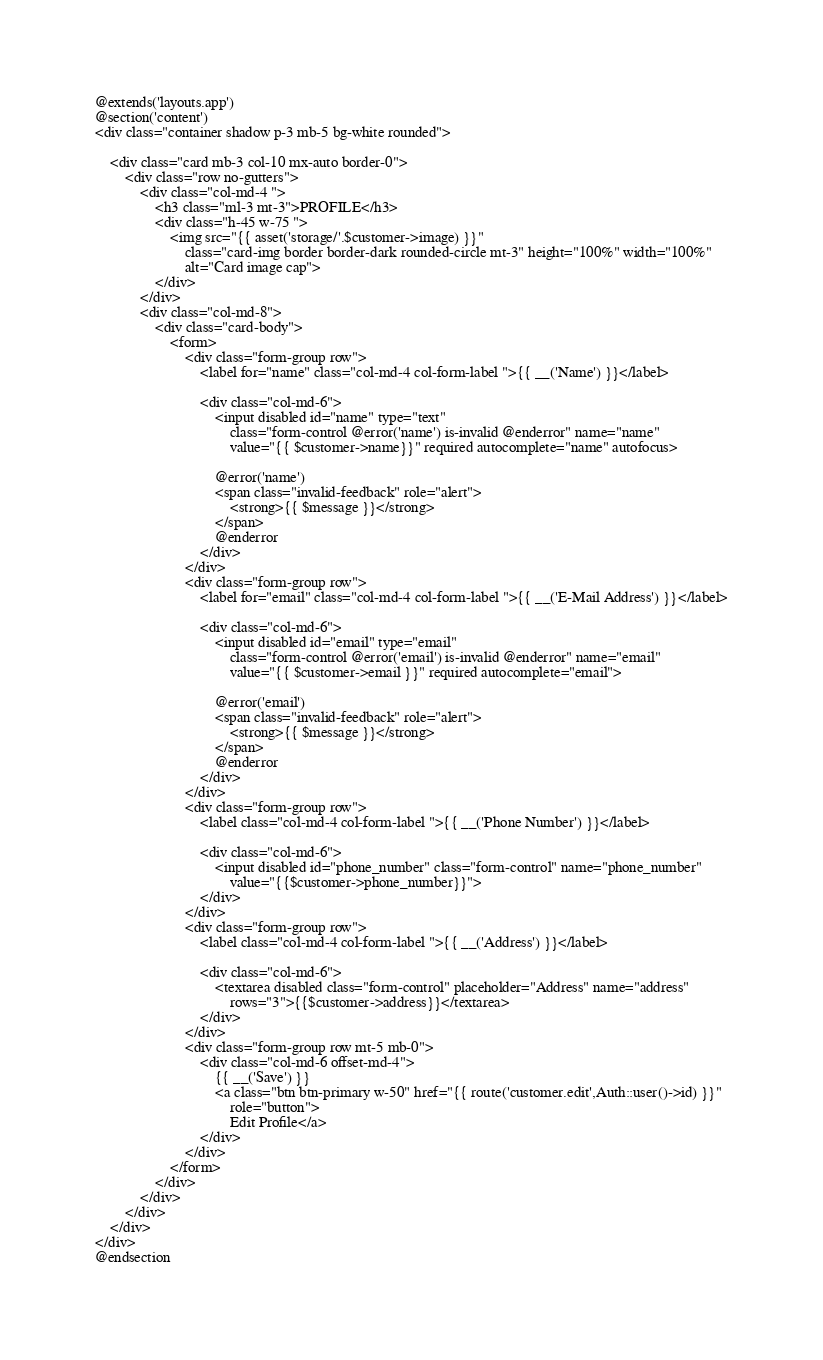<code> <loc_0><loc_0><loc_500><loc_500><_PHP_>@extends('layouts.app')
@section('content')
<div class="container shadow p-3 mb-5 bg-white rounded">

    <div class="card mb-3 col-10 mx-auto border-0">
        <div class="row no-gutters">
            <div class="col-md-4 ">
                <h3 class="ml-3 mt-3">PROFILE</h3>
                <div class="h-45 w-75 ">
                    <img src="{{ asset('storage/'.$customer->image) }}"
                        class="card-img border border-dark rounded-circle mt-3" height="100%" width="100%"
                        alt="Card image cap">
                </div>
            </div>
            <div class="col-md-8">
                <div class="card-body">
                    <form>
                        <div class="form-group row">
                            <label for="name" class="col-md-4 col-form-label ">{{ __('Name') }}</label>

                            <div class="col-md-6">
                                <input disabled id="name" type="text"
                                    class="form-control @error('name') is-invalid @enderror" name="name"
                                    value="{{ $customer->name}}" required autocomplete="name" autofocus>

                                @error('name')
                                <span class="invalid-feedback" role="alert">
                                    <strong>{{ $message }}</strong>
                                </span>
                                @enderror
                            </div>
                        </div>
                        <div class="form-group row">
                            <label for="email" class="col-md-4 col-form-label ">{{ __('E-Mail Address') }}</label>

                            <div class="col-md-6">
                                <input disabled id="email" type="email"
                                    class="form-control @error('email') is-invalid @enderror" name="email"
                                    value="{{ $customer->email }}" required autocomplete="email">

                                @error('email')
                                <span class="invalid-feedback" role="alert">
                                    <strong>{{ $message }}</strong>
                                </span>
                                @enderror
                            </div>
                        </div>
                        <div class="form-group row">
                            <label class="col-md-4 col-form-label ">{{ __('Phone Number') }}</label>

                            <div class="col-md-6">
                                <input disabled id="phone_number" class="form-control" name="phone_number"
                                    value="{{$customer->phone_number}}">
                            </div>
                        </div>
                        <div class="form-group row">
                            <label class="col-md-4 col-form-label ">{{ __('Address') }}</label>

                            <div class="col-md-6">
                                <textarea disabled class="form-control" placeholder="Address" name="address"
                                    rows="3">{{$customer->address}}</textarea>
                            </div>
                        </div>
                        <div class="form-group row mt-5 mb-0">
                            <div class="col-md-6 offset-md-4">
                                {{ __('Save') }}
                                <a class="btn btn-primary w-50" href="{{ route('customer.edit',Auth::user()->id) }}"
                                    role="button">
                                    Edit Profile</a>
                            </div>
                        </div>
                    </form>
                </div>
            </div>
        </div>
    </div>
</div>
@endsection</code> 